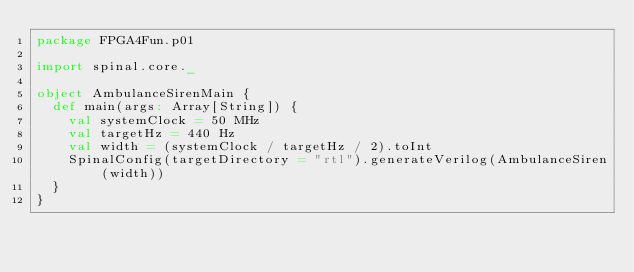<code> <loc_0><loc_0><loc_500><loc_500><_Scala_>package FPGA4Fun.p01

import spinal.core._

object AmbulanceSirenMain {
  def main(args: Array[String]) {
    val systemClock = 50 MHz
    val targetHz = 440 Hz
    val width = (systemClock / targetHz / 2).toInt
    SpinalConfig(targetDirectory = "rtl").generateVerilog(AmbulanceSiren(width))
  }
}</code> 